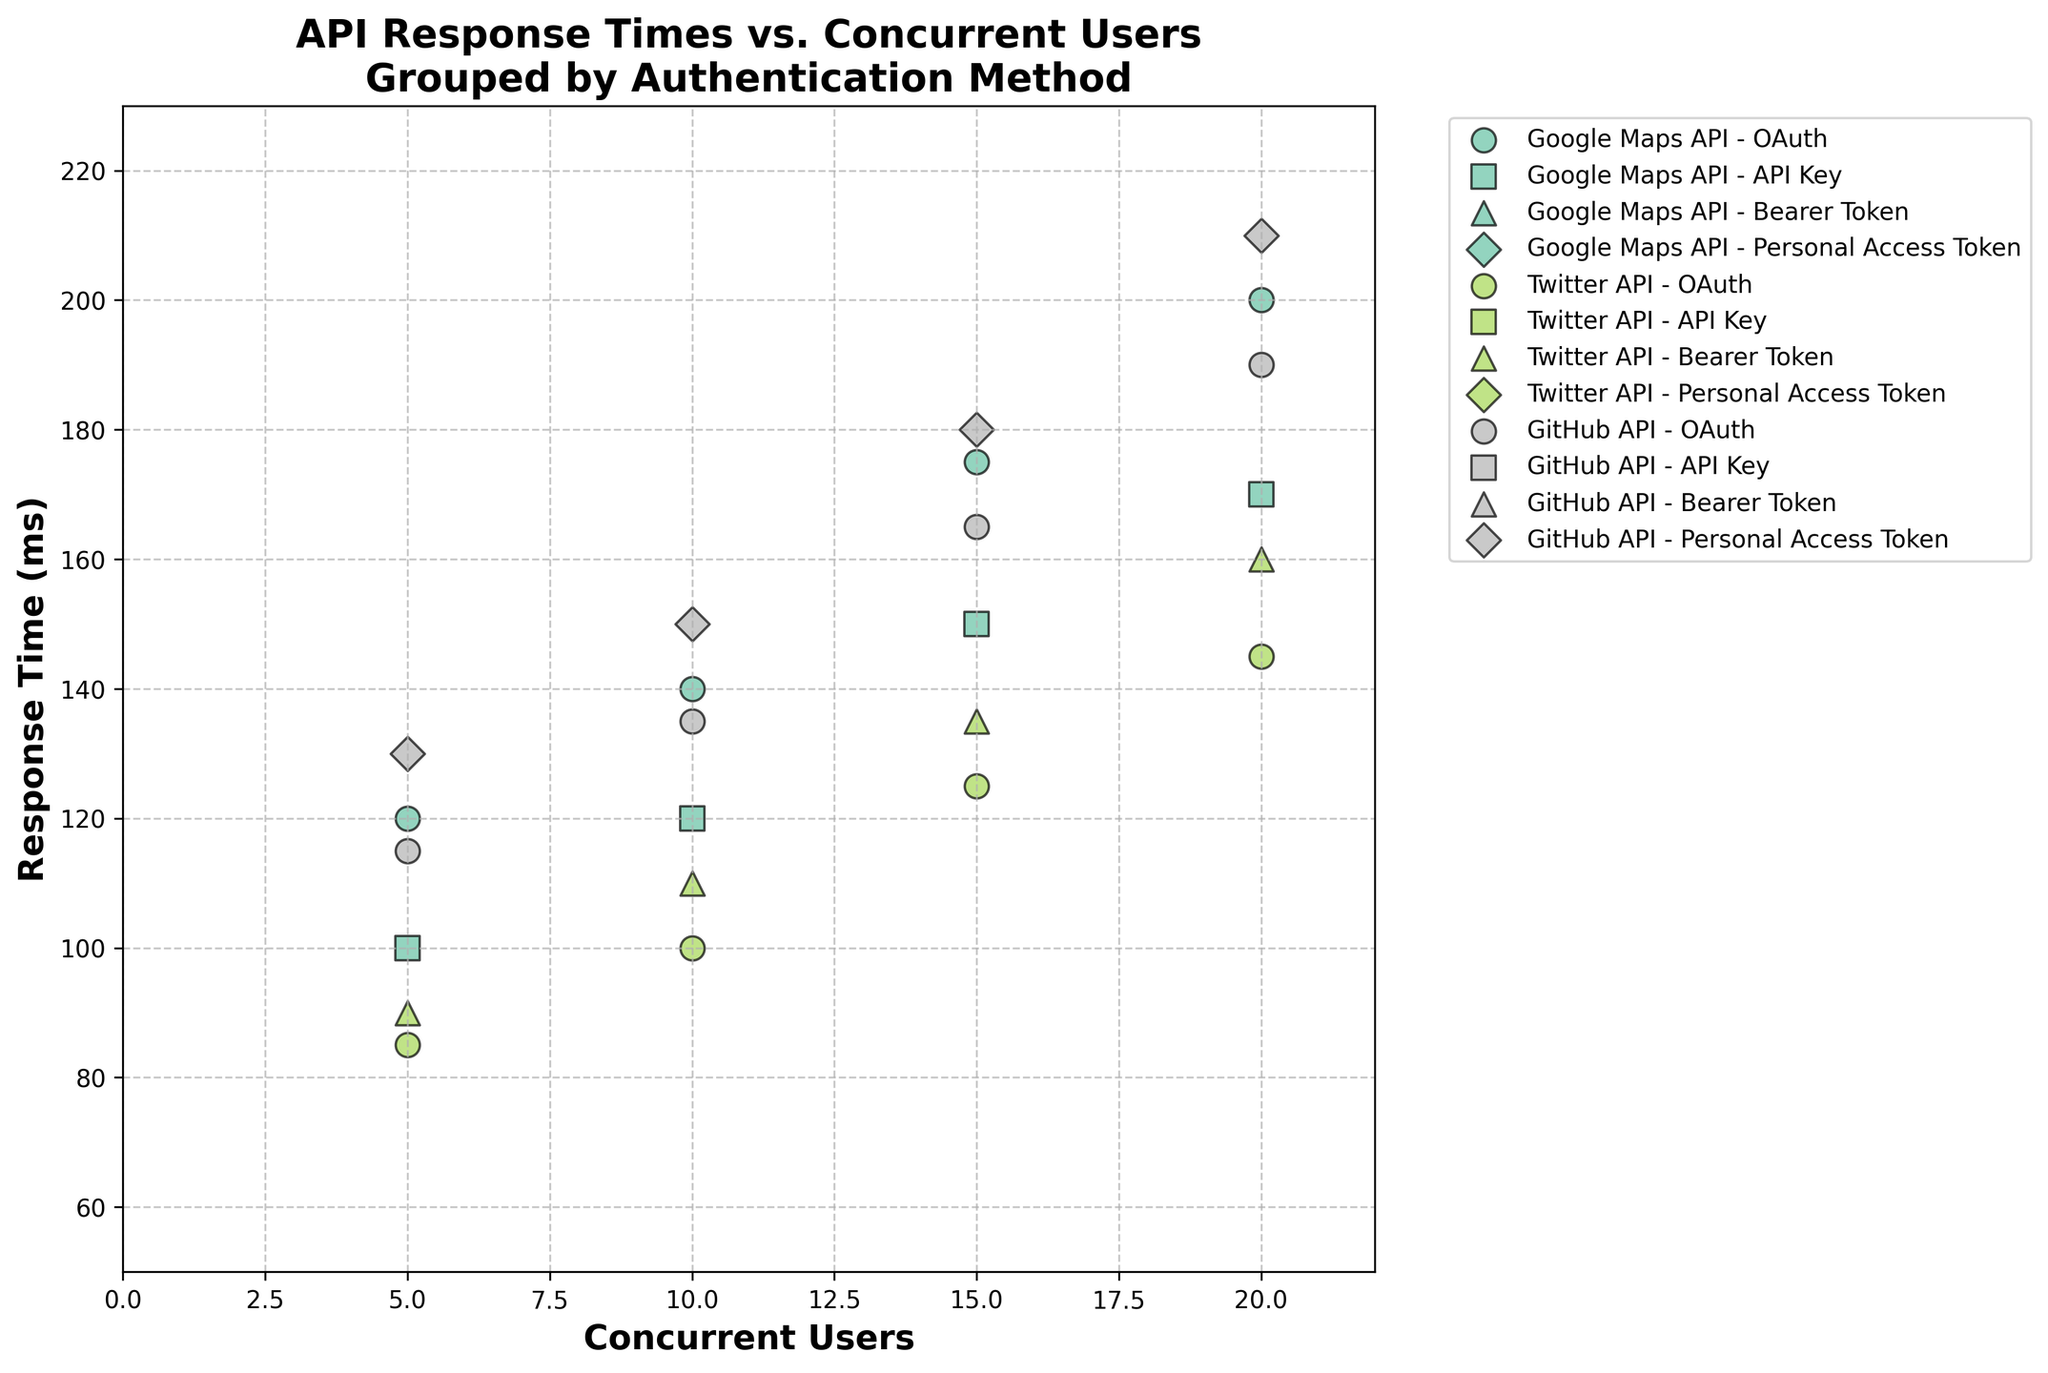What is the title of the plot? The title is displayed at the top of the plot, indicating the main theme or focus of the graph. Here, the title is placed centrally at the top of the figure and describes the essence of the plot.
Answer: API Response Times vs. Concurrent Users Grouped by Authentication Method What does the x-axis represent? The label on the x-axis details the variable represented horizontally across the plot. From the plot, we can see it's labeled with the name of the variable.
Answer: Concurrent Users How many concurrent users are represented on the x-axis? By examining the x-axis, we can count the number of ticks or labels displayed along the axis, from the smallest to the largest value.
Answer: 5, 10, 15, 20 Which API shows the highest response time for 20 concurrent users? We need to look for the points plotted at the x-value of 20, then identify the highest y-value among them. There should be three different points corresponding to each API with 20 concurrent users; we compare their y-values.
Answer: GitHub API (Personal Access Token) Which authentication method appears to have the lowest response time for the Twitter API? Among the Twitter API data points, locate both sets of points (OAuth and Bearer Token) and identify the one with the lowest y-values. Compare the smallest points for each method to find the lower one.
Answer: OAuth How does the response time of the Google Maps API with OAuth compare to that with an API Key at 15 concurrent users? Compare the y-values of the Google Maps API for the OAuth and API Key data points when the x-value is 15 concurrent users. Point out the heights of both markers for detailed comparison.
Answer: OAuth is higher What is the trend in response times for the GitHub API when using Personal Access Tokens as the number of concurrent users increases? Examine the overall pattern from the points for GitHub API with Personal Access Tokens. Notice whether the y-values generally increase, decrease, or remain the same as the x-values increase.
Answer: Increasing Which authentication method shows more consistent response times as the number of concurrent users increases for the Twitter API? Analyze the spread and direction of points for Twitter API with each authentication method. Determine which method has a more linear or predictable pattern.
Answer: Bearer Token Which API generally performs better in terms of response times for 10 concurrent users? For each API, find and compare the y-values when the x-value is 10. The API with the lowest y-value at this point is considered performing better.
Answer: Twitter API (OAuth) 